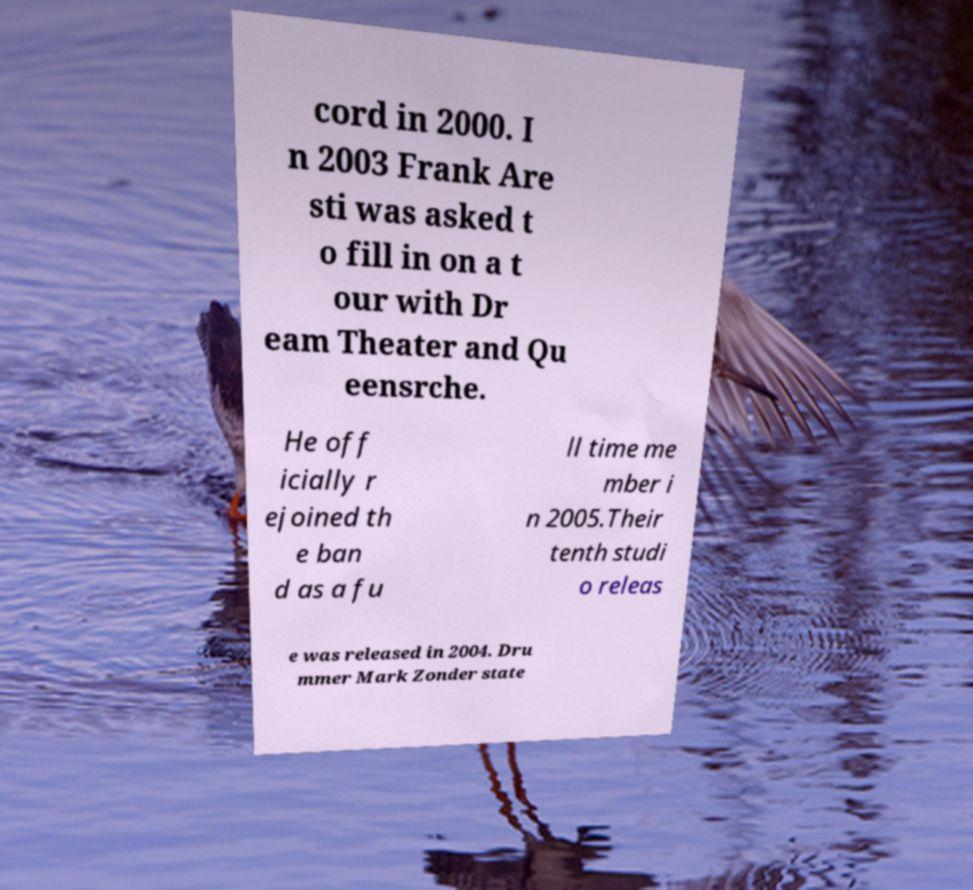Can you read and provide the text displayed in the image?This photo seems to have some interesting text. Can you extract and type it out for me? cord in 2000. I n 2003 Frank Are sti was asked t o fill in on a t our with Dr eam Theater and Qu eensrche. He off icially r ejoined th e ban d as a fu ll time me mber i n 2005.Their tenth studi o releas e was released in 2004. Dru mmer Mark Zonder state 